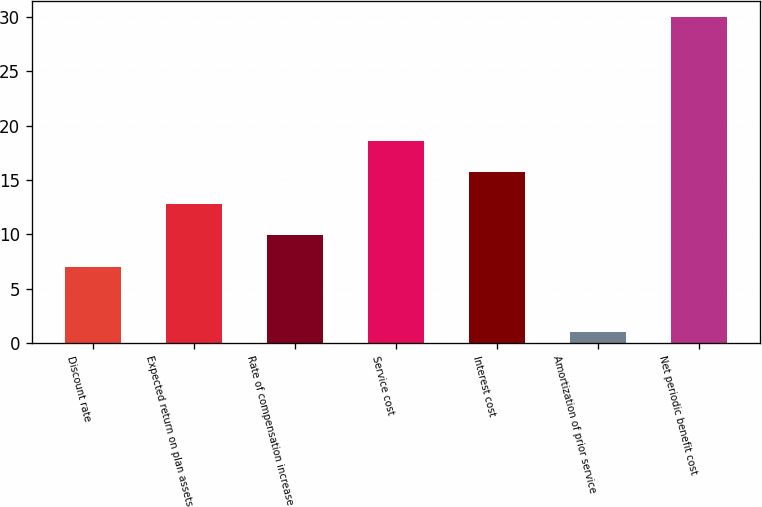Convert chart to OTSL. <chart><loc_0><loc_0><loc_500><loc_500><bar_chart><fcel>Discount rate<fcel>Expected return on plan assets<fcel>Rate of compensation increase<fcel>Service cost<fcel>Interest cost<fcel>Amortization of prior service<fcel>Net periodic benefit cost<nl><fcel>7<fcel>12.8<fcel>9.9<fcel>18.6<fcel>15.7<fcel>1<fcel>30<nl></chart> 